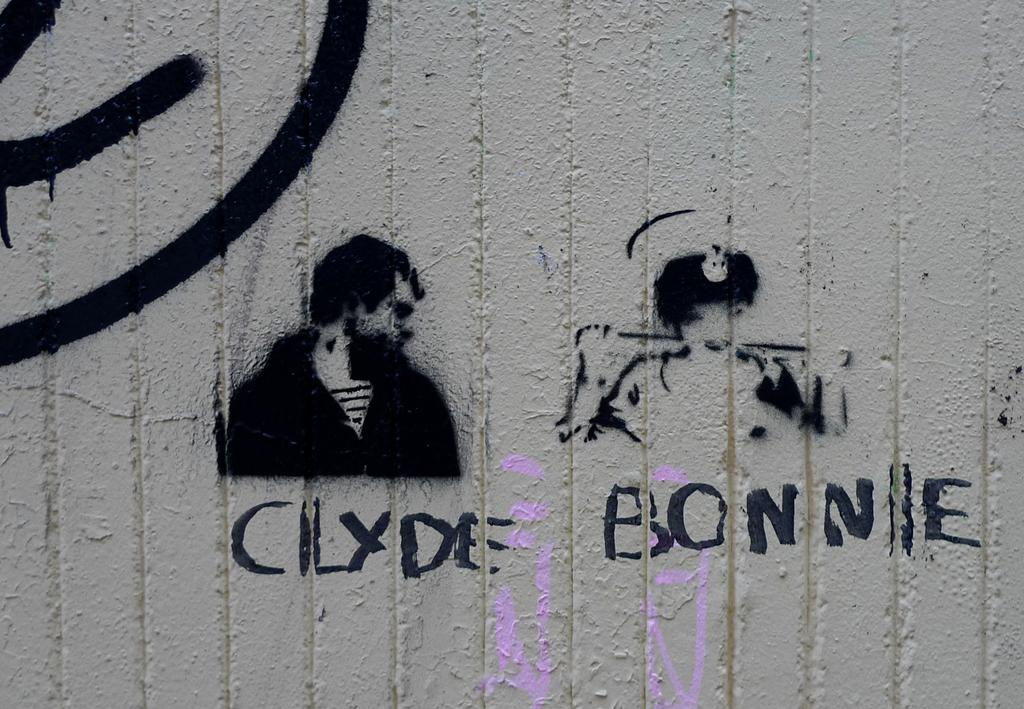What color is the wall in the image? The wall in the image is cream colored. What is on the wall in the image? There is a painting on the wall. What does the painting depict? The painting depicts a person wearing a black dress. What color are the words written in the image? The words are written in black color in the image. How many degrees can be seen in the image? There are no degrees visible in the image. What type of stone is depicted in the image? There is no stone depicted in the image. 